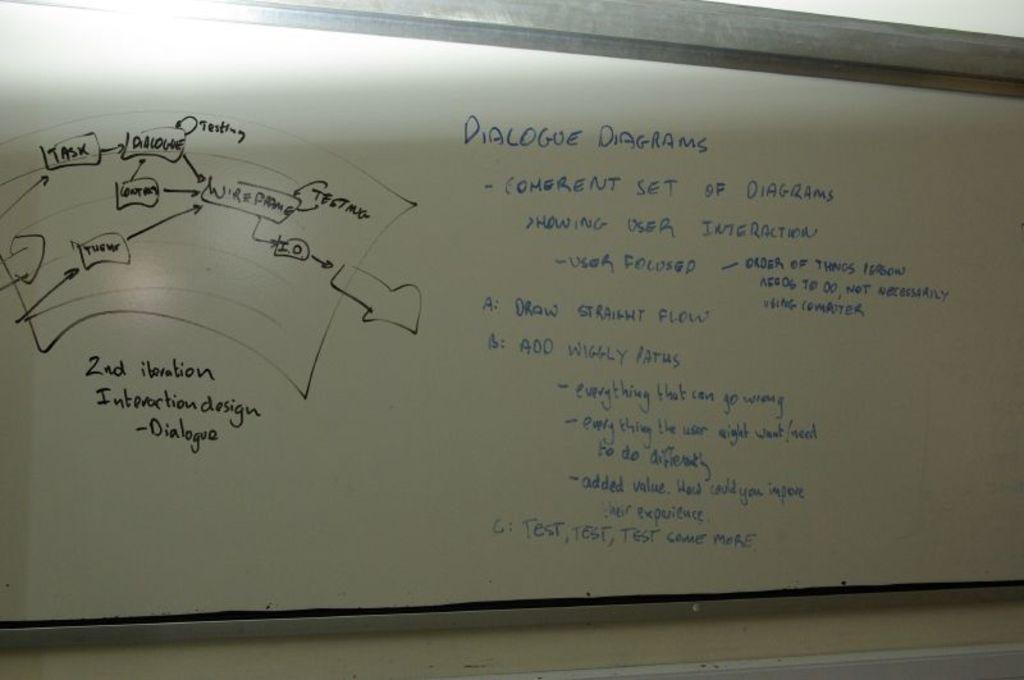<image>
Share a concise interpretation of the image provided. A diagram and the heading Dialogue Diagrams on a white board. 